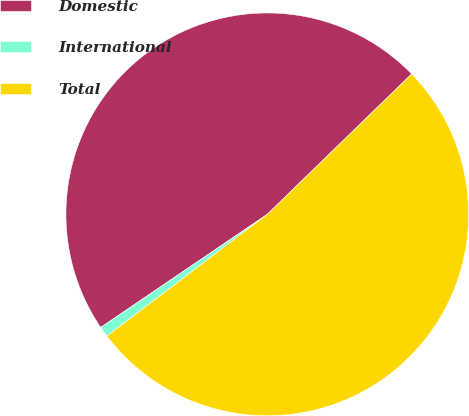Convert chart. <chart><loc_0><loc_0><loc_500><loc_500><pie_chart><fcel>Domestic<fcel>International<fcel>Total<nl><fcel>47.22%<fcel>0.84%<fcel>51.94%<nl></chart> 